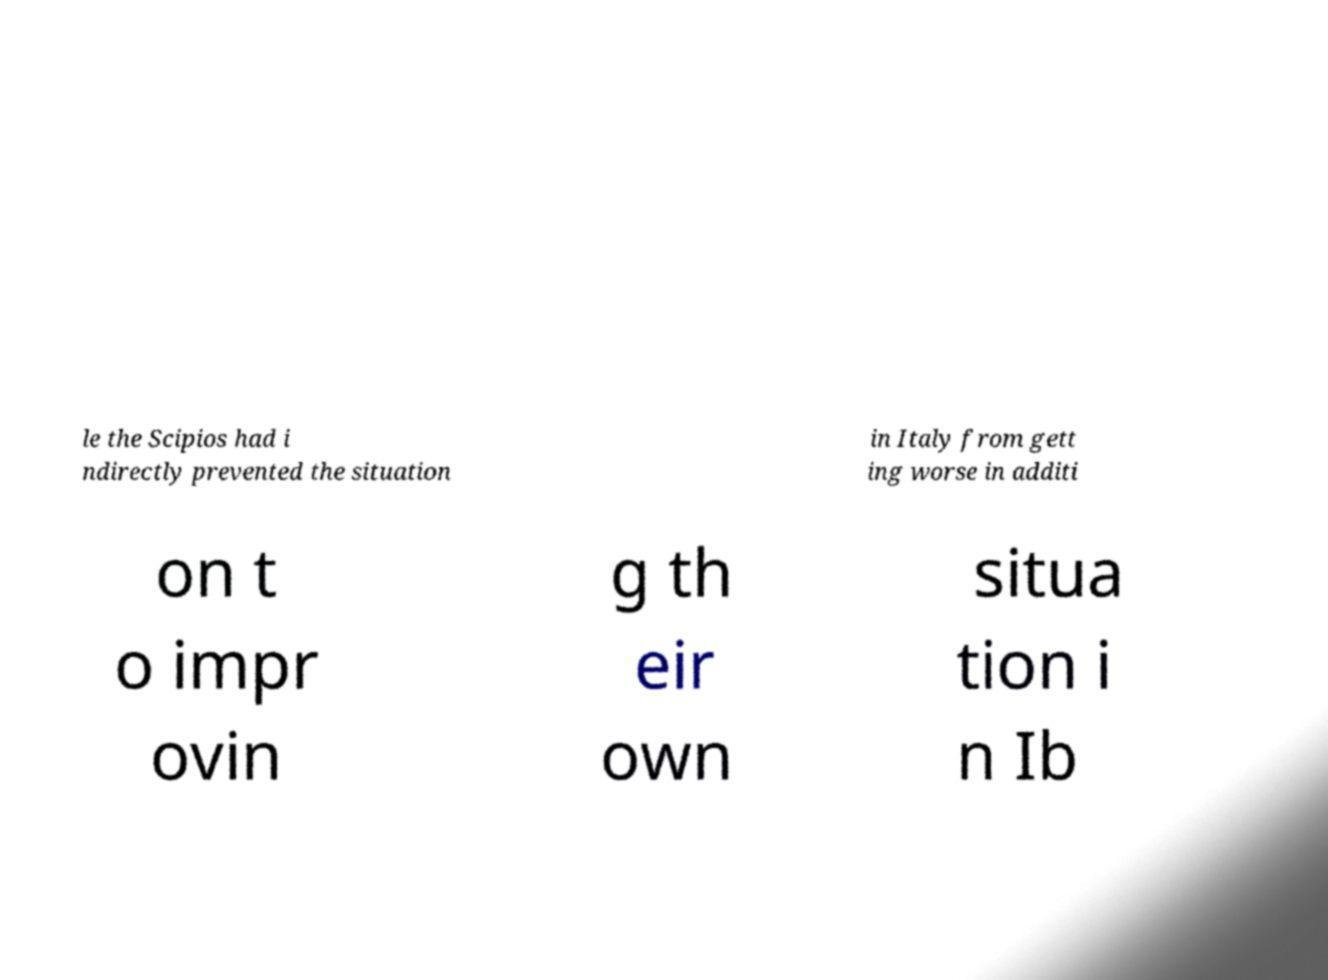Please identify and transcribe the text found in this image. le the Scipios had i ndirectly prevented the situation in Italy from gett ing worse in additi on t o impr ovin g th eir own situa tion i n Ib 